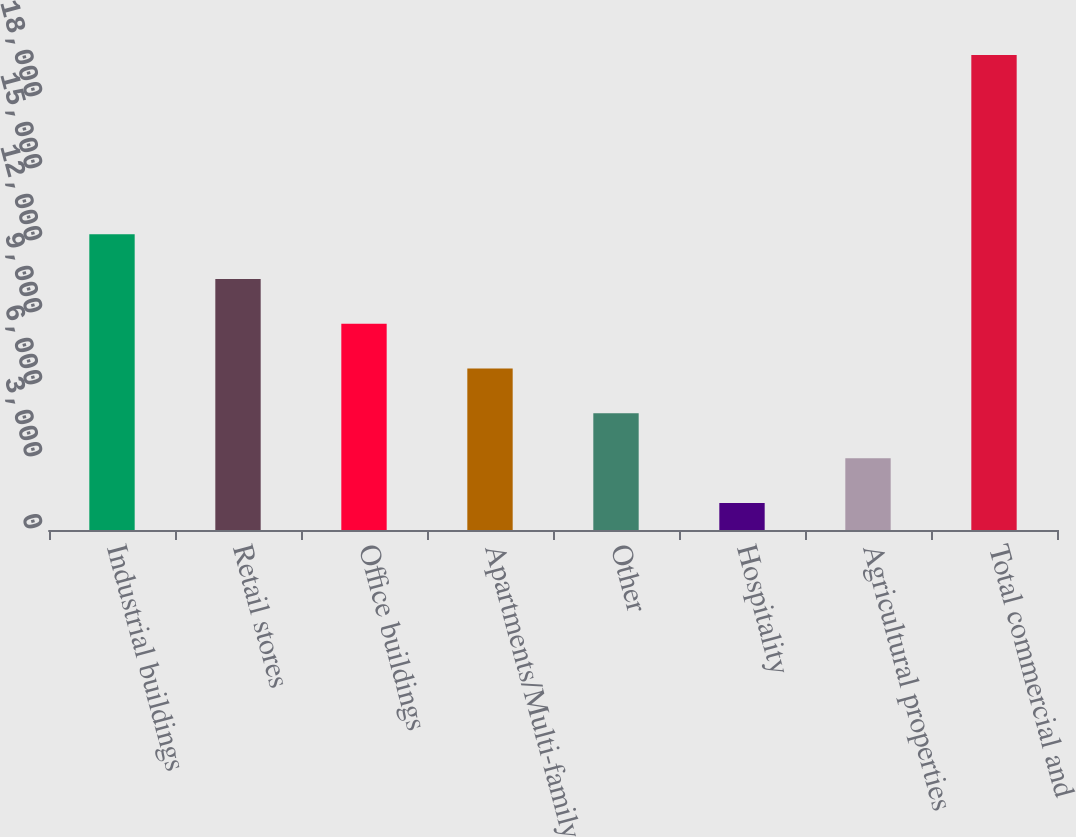Convert chart to OTSL. <chart><loc_0><loc_0><loc_500><loc_500><bar_chart><fcel>Industrial buildings<fcel>Retail stores<fcel>Office buildings<fcel>Apartments/Multi-family<fcel>Other<fcel>Hospitality<fcel>Agricultural properties<fcel>Total commercial and<nl><fcel>12328<fcel>10461<fcel>8594<fcel>6727<fcel>4860<fcel>1126<fcel>2993<fcel>19796<nl></chart> 